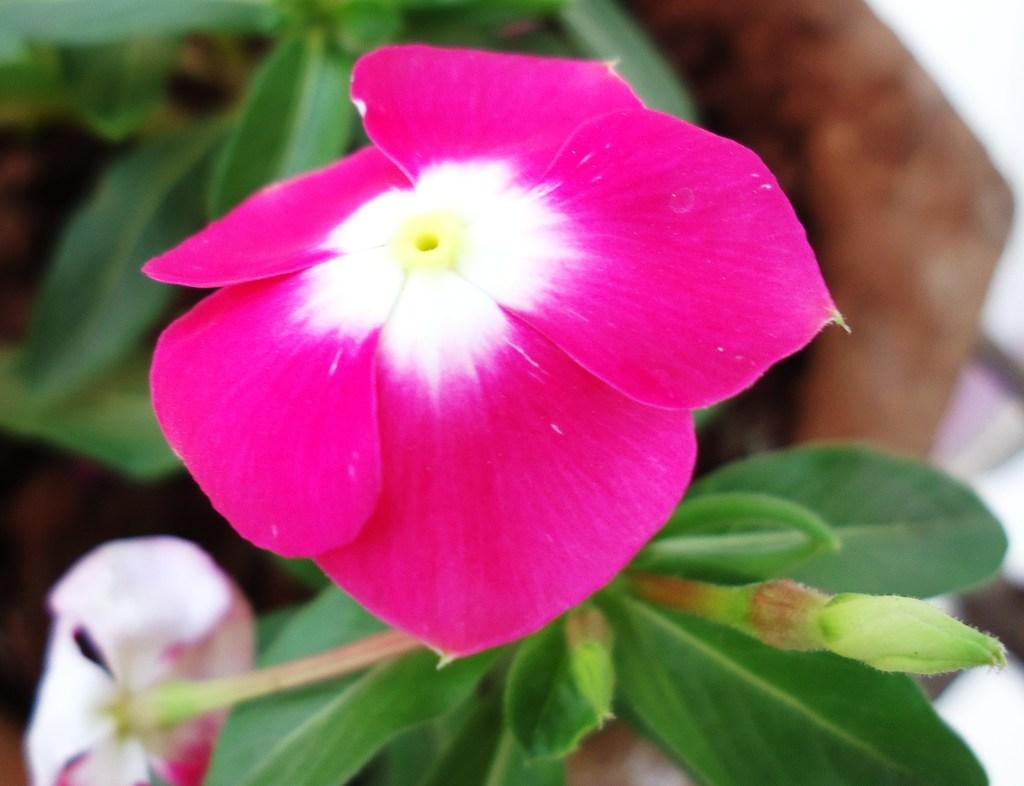What type of living organism can be seen in the image? There is a plant in the image. Where is the plant located? The plant is in a flower pot. What type of office furniture is visible in the image? There is no office furniture present in the image; it features a plant in a flower pot. How does the wish affect the plant's growth in the image? There is no mention of a wish in the image, and wishes do not have a direct impact on plant growth. 